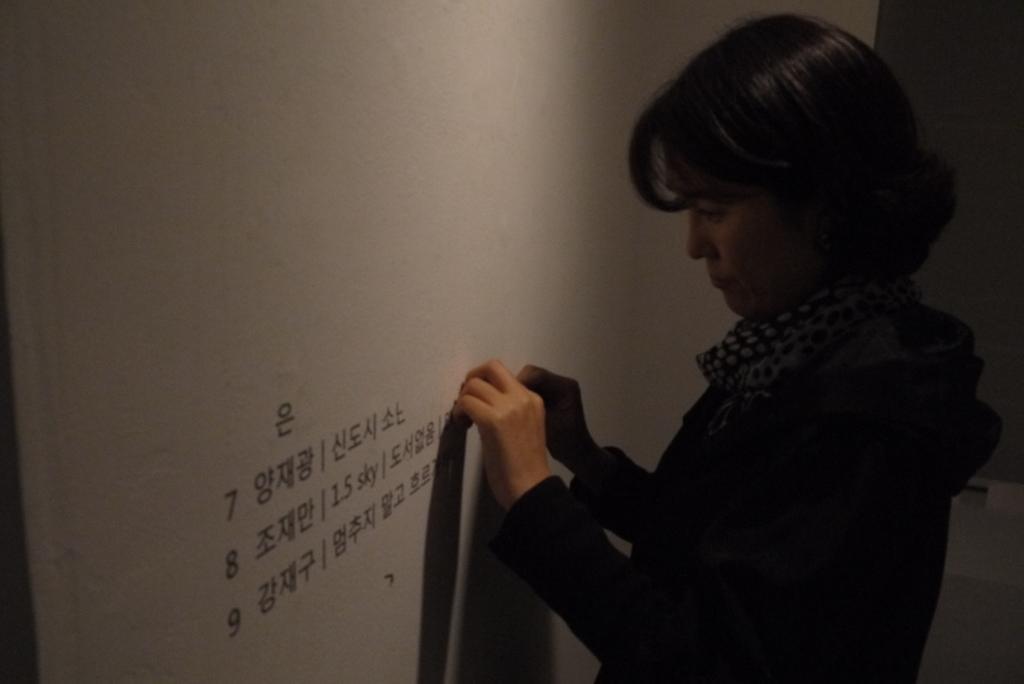How would you summarize this image in a sentence or two? In this image there is a woman on the right side who is pasting the stickers on the wall which is in front of her. 